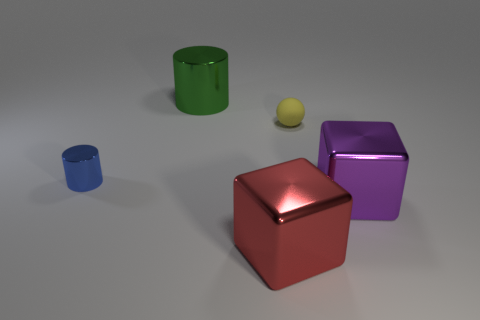Imagine if these objects represented a family, what roles would they play? What a creative concept! If we were to anthropomorphize these objects into a family, we might imagine the large red cube as a parental figure due to its size and central position. The purple cube could be considered as a sibling due to its proximity in size and placement. The little blue cylinder could be a pet or a younger sibling, given its smaller size and distance from the central figures. The yellow sphere might be a cherished family object or toy, and the green cylinder could be a relative or a family friend, providing support from the side. 